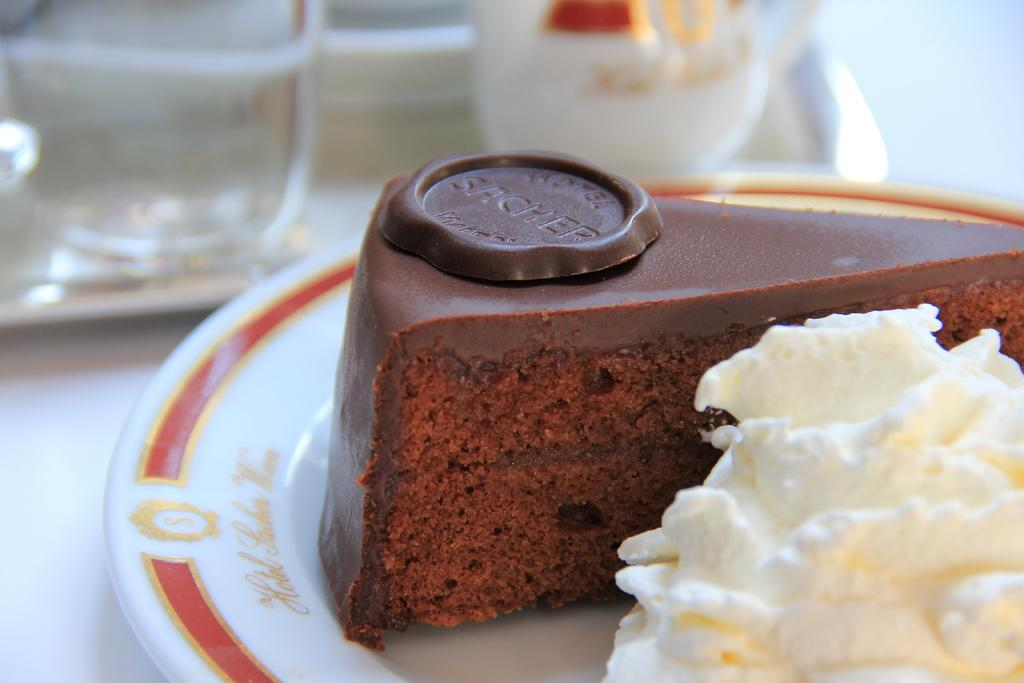What is the color of the plate in the image? The plate in the image is white with a red border. What can be seen on the plate? There is a chocolate cake piece and white cream on the plate. Is there any text or writing on the plate? Yes, there is something written on the plate. How would you describe the background of the image? The background of the image is blurred. What type of songs can be heard playing in the background of the image? There is no audio or music present in the image, so it is not possible to determine what songs might be heard. 